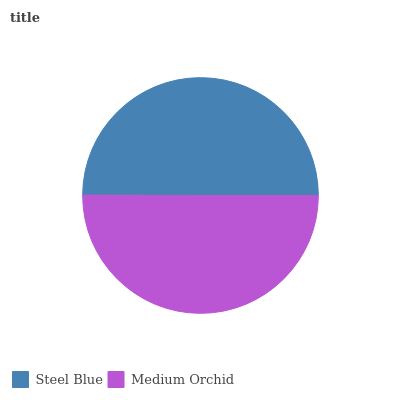Is Steel Blue the minimum?
Answer yes or no. Yes. Is Medium Orchid the maximum?
Answer yes or no. Yes. Is Medium Orchid the minimum?
Answer yes or no. No. Is Medium Orchid greater than Steel Blue?
Answer yes or no. Yes. Is Steel Blue less than Medium Orchid?
Answer yes or no. Yes. Is Steel Blue greater than Medium Orchid?
Answer yes or no. No. Is Medium Orchid less than Steel Blue?
Answer yes or no. No. Is Medium Orchid the high median?
Answer yes or no. Yes. Is Steel Blue the low median?
Answer yes or no. Yes. Is Steel Blue the high median?
Answer yes or no. No. Is Medium Orchid the low median?
Answer yes or no. No. 